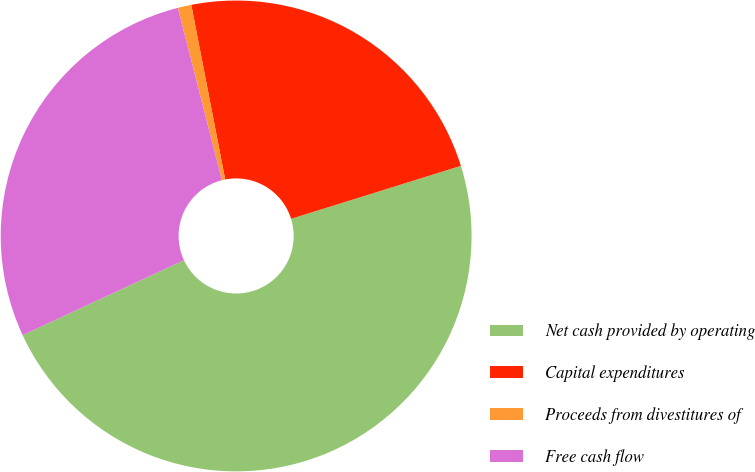Convert chart. <chart><loc_0><loc_0><loc_500><loc_500><pie_chart><fcel>Net cash provided by operating<fcel>Capital expenditures<fcel>Proceeds from divestitures of<fcel>Free cash flow<nl><fcel>47.89%<fcel>23.24%<fcel>0.93%<fcel>27.94%<nl></chart> 